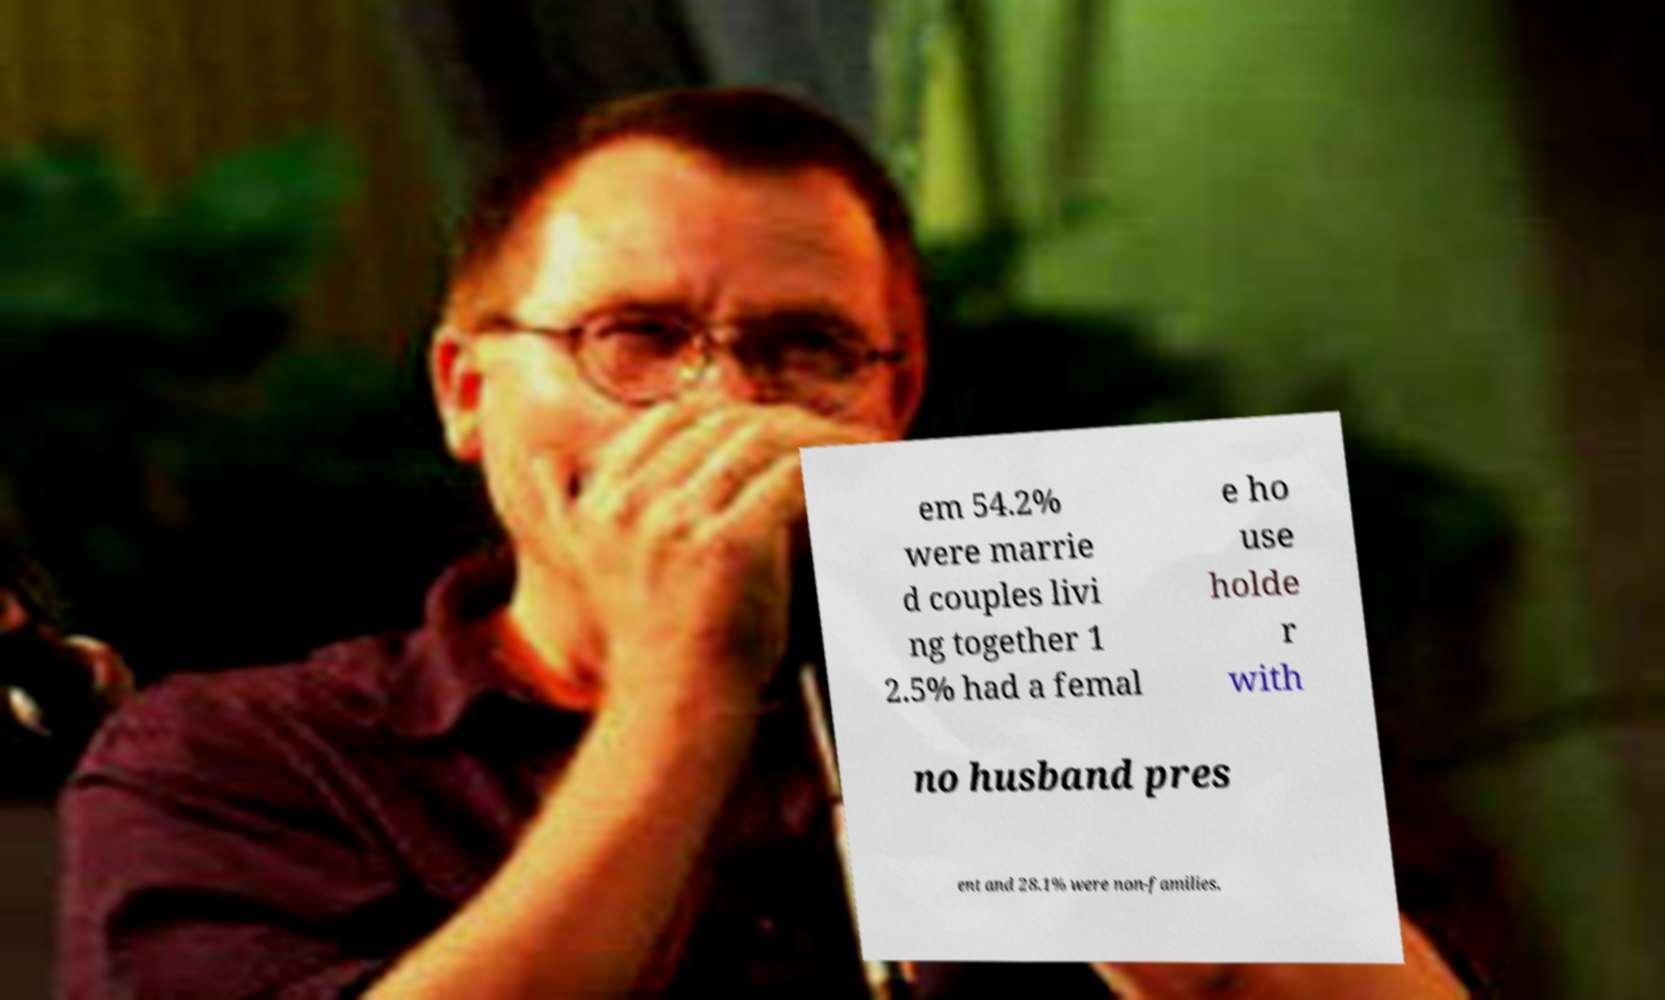There's text embedded in this image that I need extracted. Can you transcribe it verbatim? em 54.2% were marrie d couples livi ng together 1 2.5% had a femal e ho use holde r with no husband pres ent and 28.1% were non-families. 